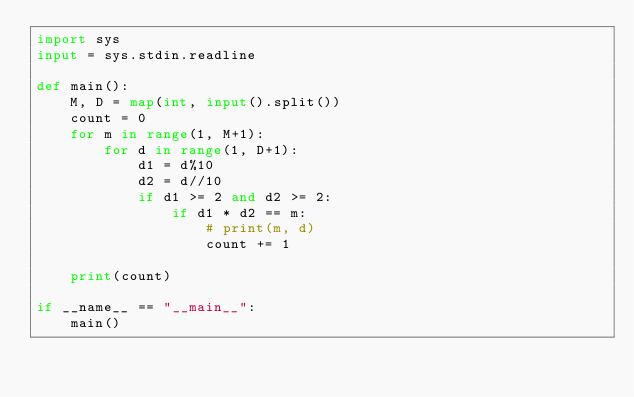<code> <loc_0><loc_0><loc_500><loc_500><_Python_>import sys
input = sys.stdin.readline

def main():
    M, D = map(int, input().split())
    count = 0
    for m in range(1, M+1):
        for d in range(1, D+1):
            d1 = d%10
            d2 = d//10
            if d1 >= 2 and d2 >= 2:
                if d1 * d2 == m:
                    # print(m, d)
                    count += 1
    
    print(count)

if __name__ == "__main__":
    main()</code> 